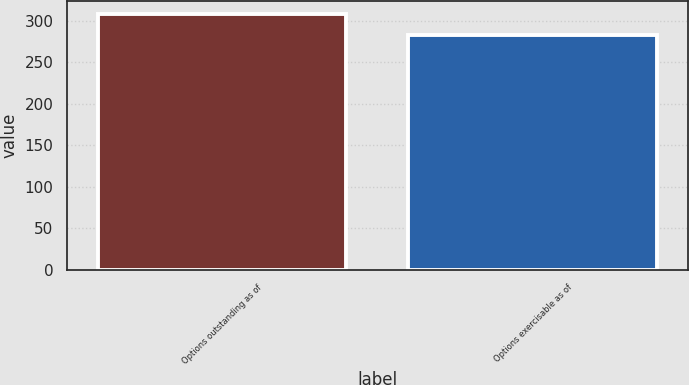Convert chart to OTSL. <chart><loc_0><loc_0><loc_500><loc_500><bar_chart><fcel>Options outstanding as of<fcel>Options exercisable as of<nl><fcel>308<fcel>283<nl></chart> 